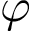<formula> <loc_0><loc_0><loc_500><loc_500>\varphi</formula> 